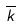<formula> <loc_0><loc_0><loc_500><loc_500>\overline { k }</formula> 